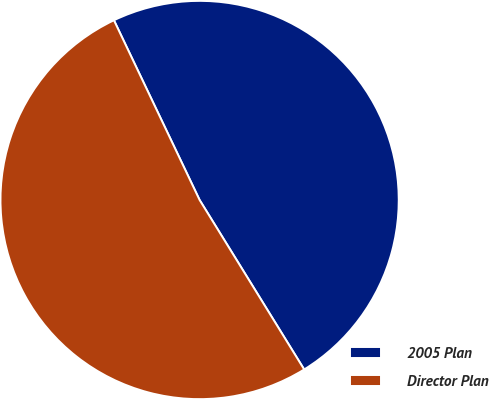Convert chart. <chart><loc_0><loc_0><loc_500><loc_500><pie_chart><fcel>2005 Plan<fcel>Director Plan<nl><fcel>48.28%<fcel>51.72%<nl></chart> 